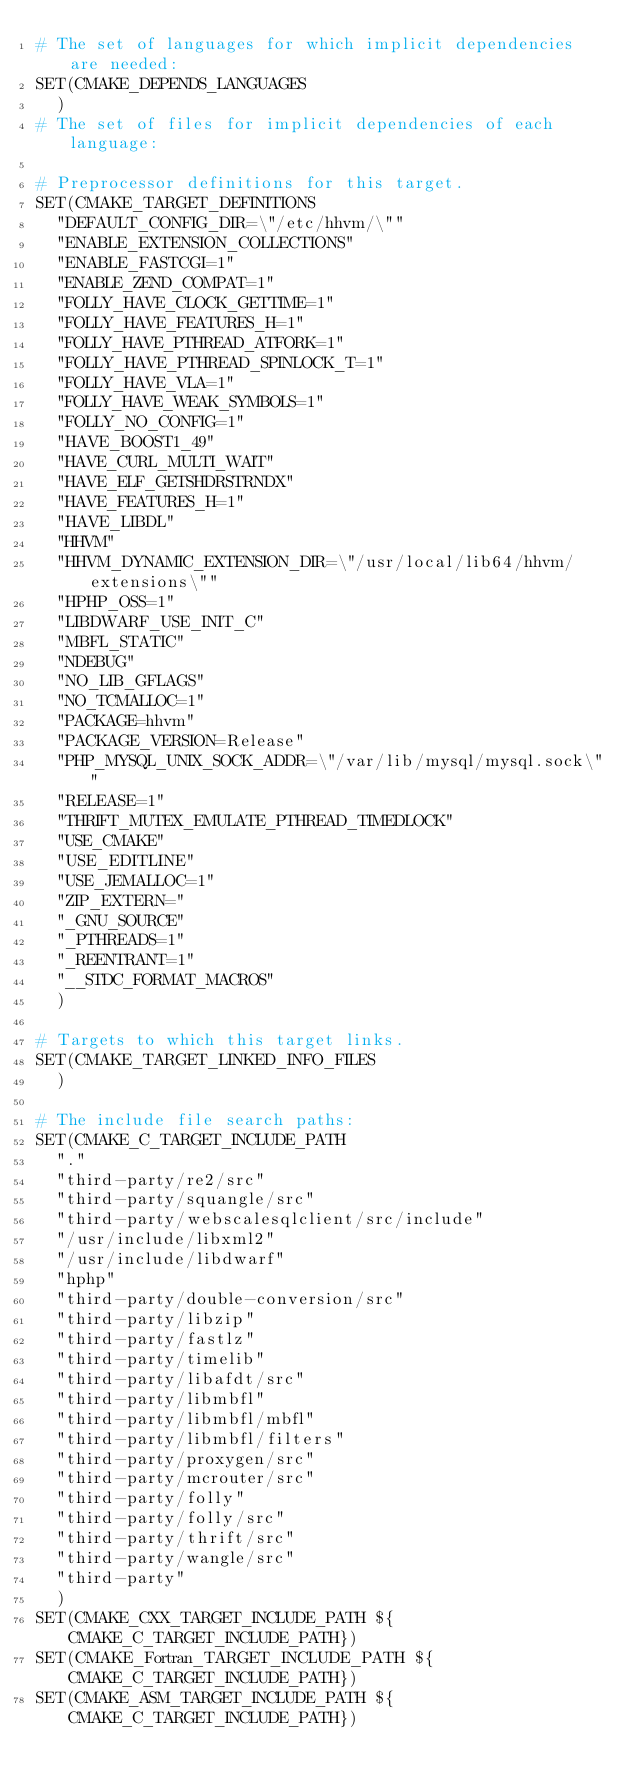Convert code to text. <code><loc_0><loc_0><loc_500><loc_500><_CMake_># The set of languages for which implicit dependencies are needed:
SET(CMAKE_DEPENDS_LANGUAGES
  )
# The set of files for implicit dependencies of each language:

# Preprocessor definitions for this target.
SET(CMAKE_TARGET_DEFINITIONS
  "DEFAULT_CONFIG_DIR=\"/etc/hhvm/\""
  "ENABLE_EXTENSION_COLLECTIONS"
  "ENABLE_FASTCGI=1"
  "ENABLE_ZEND_COMPAT=1"
  "FOLLY_HAVE_CLOCK_GETTIME=1"
  "FOLLY_HAVE_FEATURES_H=1"
  "FOLLY_HAVE_PTHREAD_ATFORK=1"
  "FOLLY_HAVE_PTHREAD_SPINLOCK_T=1"
  "FOLLY_HAVE_VLA=1"
  "FOLLY_HAVE_WEAK_SYMBOLS=1"
  "FOLLY_NO_CONFIG=1"
  "HAVE_BOOST1_49"
  "HAVE_CURL_MULTI_WAIT"
  "HAVE_ELF_GETSHDRSTRNDX"
  "HAVE_FEATURES_H=1"
  "HAVE_LIBDL"
  "HHVM"
  "HHVM_DYNAMIC_EXTENSION_DIR=\"/usr/local/lib64/hhvm/extensions\""
  "HPHP_OSS=1"
  "LIBDWARF_USE_INIT_C"
  "MBFL_STATIC"
  "NDEBUG"
  "NO_LIB_GFLAGS"
  "NO_TCMALLOC=1"
  "PACKAGE=hhvm"
  "PACKAGE_VERSION=Release"
  "PHP_MYSQL_UNIX_SOCK_ADDR=\"/var/lib/mysql/mysql.sock\""
  "RELEASE=1"
  "THRIFT_MUTEX_EMULATE_PTHREAD_TIMEDLOCK"
  "USE_CMAKE"
  "USE_EDITLINE"
  "USE_JEMALLOC=1"
  "ZIP_EXTERN="
  "_GNU_SOURCE"
  "_PTHREADS=1"
  "_REENTRANT=1"
  "__STDC_FORMAT_MACROS"
  )

# Targets to which this target links.
SET(CMAKE_TARGET_LINKED_INFO_FILES
  )

# The include file search paths:
SET(CMAKE_C_TARGET_INCLUDE_PATH
  "."
  "third-party/re2/src"
  "third-party/squangle/src"
  "third-party/webscalesqlclient/src/include"
  "/usr/include/libxml2"
  "/usr/include/libdwarf"
  "hphp"
  "third-party/double-conversion/src"
  "third-party/libzip"
  "third-party/fastlz"
  "third-party/timelib"
  "third-party/libafdt/src"
  "third-party/libmbfl"
  "third-party/libmbfl/mbfl"
  "third-party/libmbfl/filters"
  "third-party/proxygen/src"
  "third-party/mcrouter/src"
  "third-party/folly"
  "third-party/folly/src"
  "third-party/thrift/src"
  "third-party/wangle/src"
  "third-party"
  )
SET(CMAKE_CXX_TARGET_INCLUDE_PATH ${CMAKE_C_TARGET_INCLUDE_PATH})
SET(CMAKE_Fortran_TARGET_INCLUDE_PATH ${CMAKE_C_TARGET_INCLUDE_PATH})
SET(CMAKE_ASM_TARGET_INCLUDE_PATH ${CMAKE_C_TARGET_INCLUDE_PATH})
</code> 